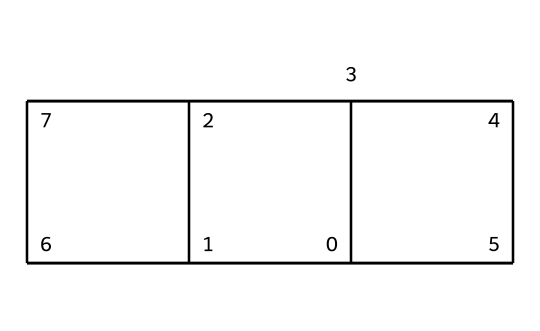What is the molecular formula of cubane? To determine the molecular formula, count the number of carbon (C) and hydrogen (H) atoms in the structure. Cubane consists of 8 carbon atoms and 8 hydrogen atoms.
Answer: C8H8 How many C-H bonds are present in cubane? Each carbon atom in cubane is bonded to hydrogen atoms. Given the structure, each of the 8 carbon atoms forms 2 bonds with neighboring carbon atoms and 2 additional bonds with hydrogen atoms, resulting in a total of 8 C-H bonds.
Answer: 8 What type of hybridization do the carbon atoms in cubane exhibit? Analyzing the geometry of cubane, the carbon atoms are arranged in a way that suggests sp3 hybridization, resulting in a tetrahedral geometry around each carbon atom when considering the bond angles.
Answer: sp3 How many faces does cubane have? The structure of cubane reveals that it is a cubic hydrocarbon. A cube has 6 faces, which corresponds to the external surface formed by its carbon atom arrangement.
Answer: 6 Are there any functional groups present in cubane? Upon examining the structure of cubane, there are no functional groups present; it consists solely of carbon and hydrogen atoms connected in a cubic arrangement, typical for a simple hydrocarbon.
Answer: No What is the geometry around each carbon atom in cubane? Each carbon atom is connected to four other atoms (two carbon atoms and two hydrogen atoms), resulting in a tetrahedral geometry around each carbon atom's central position, which is characteristic of sp3 hybridization.
Answer: Tetrahedral Is cubane a cage compound? Yes, cubane is indeed categorized as a cage compound because of its three-dimensional structure where carbon atoms are connected in a way that forms a cubic cage-like configuration.
Answer: Yes 